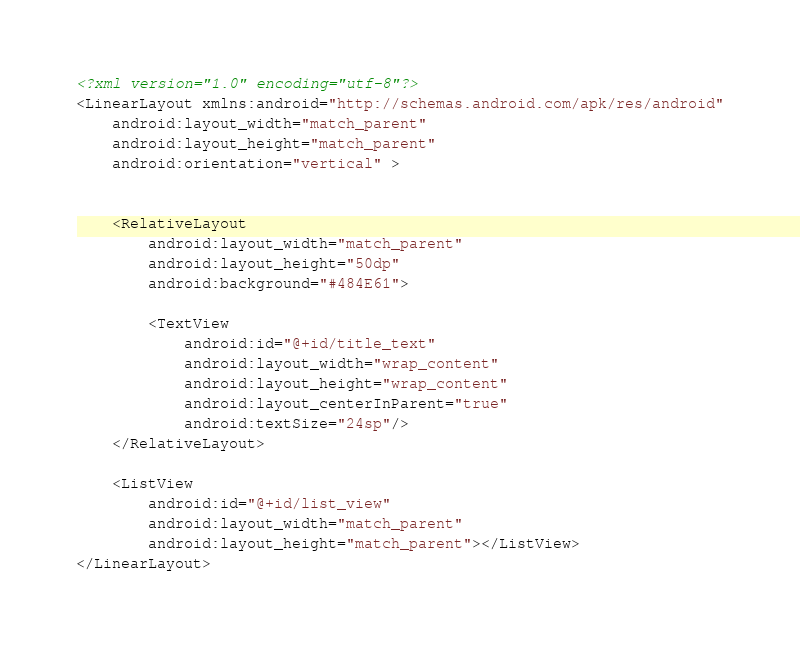<code> <loc_0><loc_0><loc_500><loc_500><_XML_><?xml version="1.0" encoding="utf-8"?>
<LinearLayout xmlns:android="http://schemas.android.com/apk/res/android"
    android:layout_width="match_parent"
    android:layout_height="match_parent"
    android:orientation="vertical" >
    

    <RelativeLayout 
        android:layout_width="match_parent"
        android:layout_height="50dp"
        android:background="#484E61">
        
        <TextView 
            android:id="@+id/title_text"
            android:layout_width="wrap_content"
            android:layout_height="wrap_content"
            android:layout_centerInParent="true"
            android:textSize="24sp"/>
    </RelativeLayout>
    
    <ListView 
        android:id="@+id/list_view"
        android:layout_width="match_parent"
        android:layout_height="match_parent"></ListView>
</LinearLayout>
</code> 